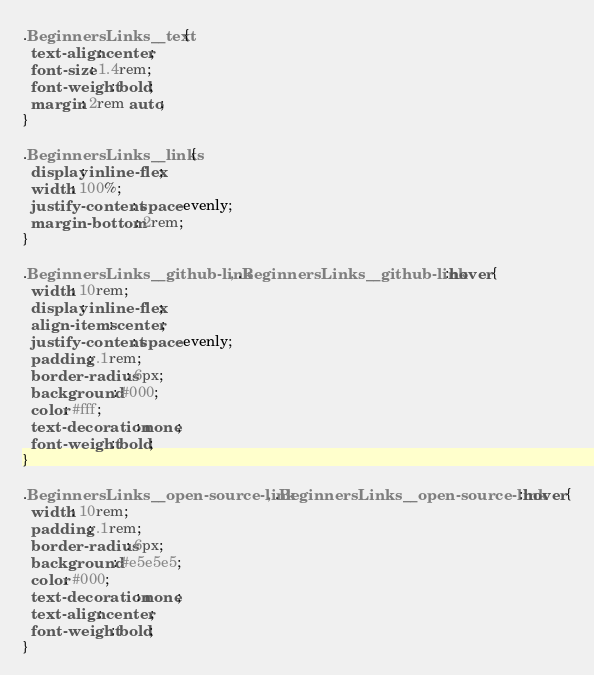Convert code to text. <code><loc_0><loc_0><loc_500><loc_500><_CSS_>.BeginnersLinks__text {
  text-align: center;
  font-size: 1.4rem;
  font-weight: bold;
  margin: 2rem auto;
}

.BeginnersLinks__links {
  display: inline-flex;
  width: 100%;
  justify-content: space-evenly;
  margin-bottom: 2rem;
}

.BeginnersLinks__github-link, .BeginnersLinks__github-link:hover {
  width: 10rem;
  display: inline-flex;
  align-items: center;
  justify-content: space-evenly;
  padding: .1rem;
  border-radius: 6px;
  background: #000;
  color: #fff;
  text-decoration: none;
  font-weight: bold;
}

.BeginnersLinks__open-source-link, .BeginnersLinks__open-source-link:hover {
  width: 10rem;
  padding: .1rem;
  border-radius: 6px;
  background: #e5e5e5;
  color: #000;
  text-decoration: none;
  text-align: center;
  font-weight: bold;
}
</code> 